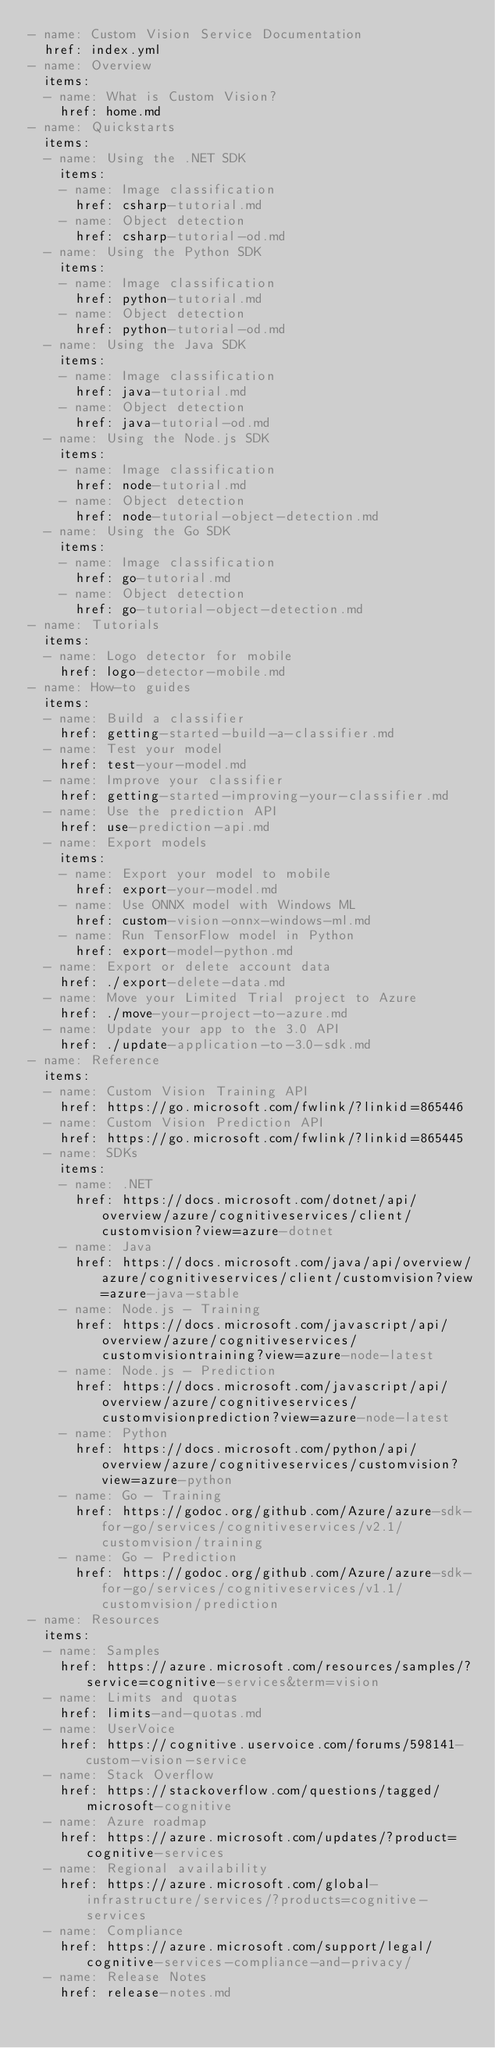<code> <loc_0><loc_0><loc_500><loc_500><_YAML_>- name: Custom Vision Service Documentation
  href: index.yml
- name: Overview
  items:
  - name: What is Custom Vision?
    href: home.md
- name: Quickstarts
  items:
  - name: Using the .NET SDK
    items:
    - name: Image classification
      href: csharp-tutorial.md
    - name: Object detection
      href: csharp-tutorial-od.md
  - name: Using the Python SDK
    items:
    - name: Image classification
      href: python-tutorial.md
    - name: Object detection
      href: python-tutorial-od.md
  - name: Using the Java SDK
    items:
    - name: Image classification
      href: java-tutorial.md
    - name: Object detection
      href: java-tutorial-od.md
  - name: Using the Node.js SDK
    items:
    - name: Image classification
      href: node-tutorial.md
    - name: Object detection
      href: node-tutorial-object-detection.md
  - name: Using the Go SDK
    items:
    - name: Image classification
      href: go-tutorial.md
    - name: Object detection
      href: go-tutorial-object-detection.md
- name: Tutorials
  items:
  - name: Logo detector for mobile
    href: logo-detector-mobile.md
- name: How-to guides
  items:
  - name: Build a classifier
    href: getting-started-build-a-classifier.md
  - name: Test your model
    href: test-your-model.md
  - name: Improve your classifier
    href: getting-started-improving-your-classifier.md
  - name: Use the prediction API
    href: use-prediction-api.md
  - name: Export models
    items:
    - name: Export your model to mobile
      href: export-your-model.md
    - name: Use ONNX model with Windows ML
      href: custom-vision-onnx-windows-ml.md
    - name: Run TensorFlow model in Python
      href: export-model-python.md
  - name: Export or delete account data
    href: ./export-delete-data.md
  - name: Move your Limited Trial project to Azure
    href: ./move-your-project-to-azure.md
  - name: Update your app to the 3.0 API
    href: ./update-application-to-3.0-sdk.md
- name: Reference
  items:
  - name: Custom Vision Training API  
    href: https://go.microsoft.com/fwlink/?linkid=865446
  - name: Custom Vision Prediction API 
    href: https://go.microsoft.com/fwlink/?linkid=865445
  - name: SDKs
    items:
    - name: .NET
      href: https://docs.microsoft.com/dotnet/api/overview/azure/cognitiveservices/client/customvision?view=azure-dotnet
    - name: Java
      href: https://docs.microsoft.com/java/api/overview/azure/cognitiveservices/client/customvision?view=azure-java-stable
    - name: Node.js - Training
      href: https://docs.microsoft.com/javascript/api/overview/azure/cognitiveservices/customvisiontraining?view=azure-node-latest
    - name: Node.js - Prediction
      href: https://docs.microsoft.com/javascript/api/overview/azure/cognitiveservices/customvisionprediction?view=azure-node-latest
    - name: Python
      href: https://docs.microsoft.com/python/api/overview/azure/cognitiveservices/customvision?view=azure-python
    - name: Go - Training
      href: https://godoc.org/github.com/Azure/azure-sdk-for-go/services/cognitiveservices/v2.1/customvision/training
    - name: Go - Prediction
      href: https://godoc.org/github.com/Azure/azure-sdk-for-go/services/cognitiveservices/v1.1/customvision/prediction
- name: Resources
  items:
  - name: Samples
    href: https://azure.microsoft.com/resources/samples/?service=cognitive-services&term=vision
  - name: Limits and quotas
    href: limits-and-quotas.md
  - name: UserVoice
    href: https://cognitive.uservoice.com/forums/598141-custom-vision-service
  - name: Stack Overflow
    href: https://stackoverflow.com/questions/tagged/microsoft-cognitive
  - name: Azure roadmap
    href: https://azure.microsoft.com/updates/?product=cognitive-services
  - name: Regional availability
    href: https://azure.microsoft.com/global-infrastructure/services/?products=cognitive-services
  - name: Compliance
    href: https://azure.microsoft.com/support/legal/cognitive-services-compliance-and-privacy/
  - name: Release Notes
    href: release-notes.md
</code> 